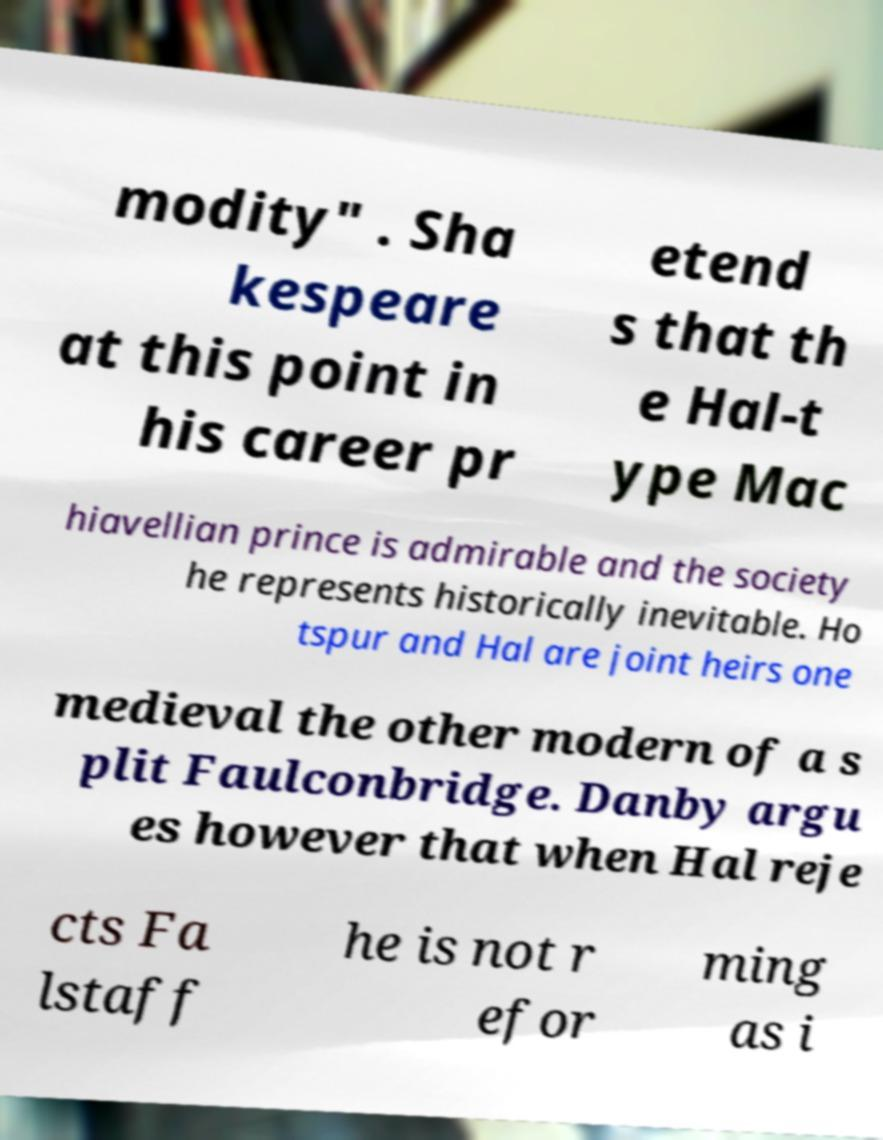Could you extract and type out the text from this image? modity" . Sha kespeare at this point in his career pr etend s that th e Hal-t ype Mac hiavellian prince is admirable and the society he represents historically inevitable. Ho tspur and Hal are joint heirs one medieval the other modern of a s plit Faulconbridge. Danby argu es however that when Hal reje cts Fa lstaff he is not r efor ming as i 